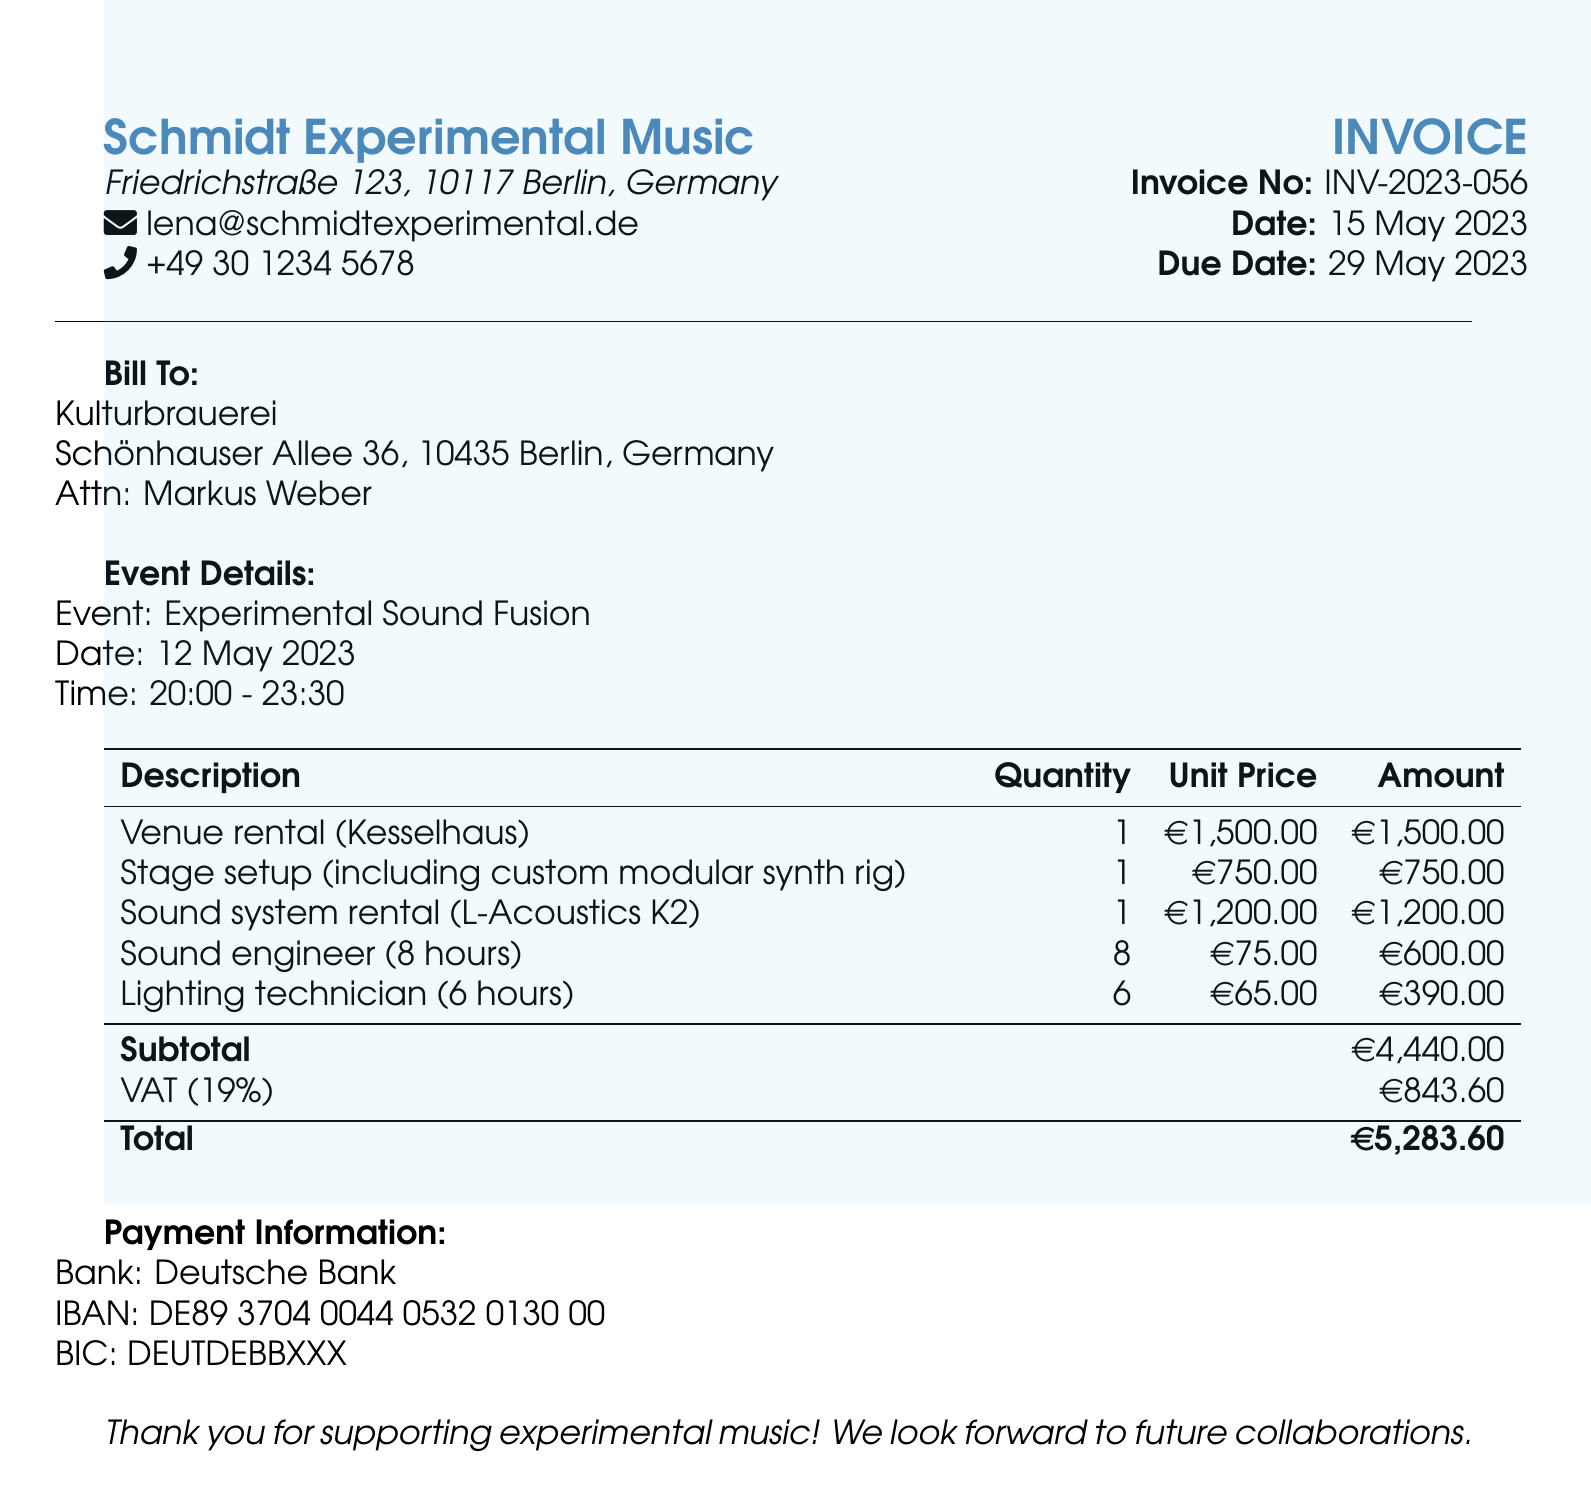What is the invoice number? The invoice number is found in the top section of the document and identifies the specific invoice.
Answer: INV-2023-056 What is the total amount due? The total amount due is calculated at the end of the invoice after VAT has been added.
Answer: €5,283.60 Who is the contact person for the bill? The contact person is listed under the "Bill To" section, responsible for the invoice.
Answer: Markus Weber What is the VAT percentage applied? The VAT percentage can be found in the line item for VAT, indicating the tax rate applied to the subtotal.
Answer: 19% How much is charged for the sound system rental? The amount for the sound system rental is indicated in the itemized breakdown of charges for services provided.
Answer: €1,200.00 What type of sound system was rented? The type of sound system can be found in the description of the sound system rental charge.
Answer: L-Acoustics K2 How many hours were worked by the sound engineer? The total hours worked by the sound engineer are included in the details of that specific service charge.
Answer: 8 hours What is the subtotal before VAT? The subtotal is the total amount before any VAT has been added and can be found in the summary of charges.
Answer: €4,440.00 What event is being billed for? The event name can be found in the "Event Details" section of the document.
Answer: Experimental Sound Fusion 